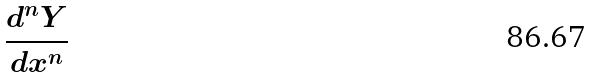Convert formula to latex. <formula><loc_0><loc_0><loc_500><loc_500>\frac { d ^ { n } Y } { d x ^ { n } }</formula> 